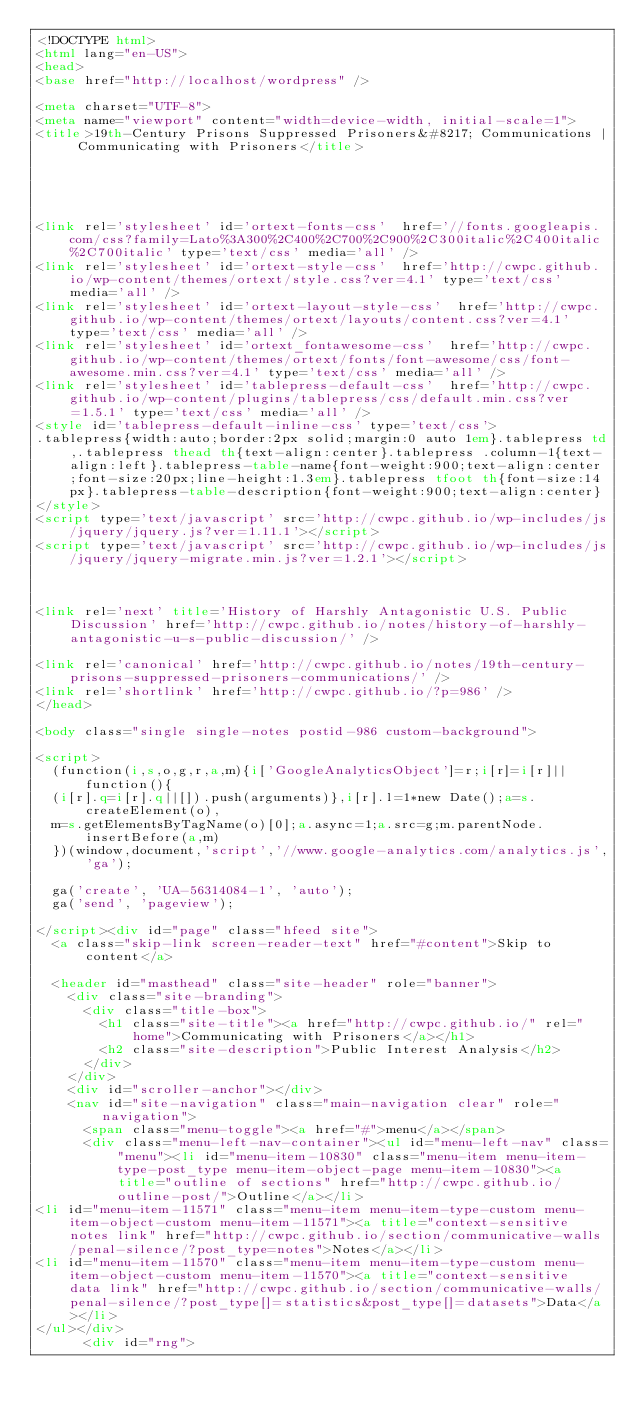Convert code to text. <code><loc_0><loc_0><loc_500><loc_500><_HTML_><!DOCTYPE html>
<html lang="en-US">
<head>
<base href="http://localhost/wordpress" />

<meta charset="UTF-8">
<meta name="viewport" content="width=device-width, initial-scale=1">
<title>19th-Century Prisons Suppressed Prisoners&#8217; Communications | Communicating with Prisoners</title>
 




<link rel='stylesheet' id='ortext-fonts-css'  href='//fonts.googleapis.com/css?family=Lato%3A300%2C400%2C700%2C900%2C300italic%2C400italic%2C700italic' type='text/css' media='all' />
<link rel='stylesheet' id='ortext-style-css'  href='http://cwpc.github.io/wp-content/themes/ortext/style.css?ver=4.1' type='text/css' media='all' />
<link rel='stylesheet' id='ortext-layout-style-css'  href='http://cwpc.github.io/wp-content/themes/ortext/layouts/content.css?ver=4.1' type='text/css' media='all' />
<link rel='stylesheet' id='ortext_fontawesome-css'  href='http://cwpc.github.io/wp-content/themes/ortext/fonts/font-awesome/css/font-awesome.min.css?ver=4.1' type='text/css' media='all' />
<link rel='stylesheet' id='tablepress-default-css'  href='http://cwpc.github.io/wp-content/plugins/tablepress/css/default.min.css?ver=1.5.1' type='text/css' media='all' />
<style id='tablepress-default-inline-css' type='text/css'>
.tablepress{width:auto;border:2px solid;margin:0 auto 1em}.tablepress td,.tablepress thead th{text-align:center}.tablepress .column-1{text-align:left}.tablepress-table-name{font-weight:900;text-align:center;font-size:20px;line-height:1.3em}.tablepress tfoot th{font-size:14px}.tablepress-table-description{font-weight:900;text-align:center}
</style>
<script type='text/javascript' src='http://cwpc.github.io/wp-includes/js/jquery/jquery.js?ver=1.11.1'></script>
<script type='text/javascript' src='http://cwpc.github.io/wp-includes/js/jquery/jquery-migrate.min.js?ver=1.2.1'></script>

 

<link rel='next' title='History of Harshly Antagonistic U.S. Public Discussion' href='http://cwpc.github.io/notes/history-of-harshly-antagonistic-u-s-public-discussion/' />

<link rel='canonical' href='http://cwpc.github.io/notes/19th-century-prisons-suppressed-prisoners-communications/' />
<link rel='shortlink' href='http://cwpc.github.io/?p=986' />
</head>

<body class="single single-notes postid-986 custom-background">

<script>
  (function(i,s,o,g,r,a,m){i['GoogleAnalyticsObject']=r;i[r]=i[r]||function(){
  (i[r].q=i[r].q||[]).push(arguments)},i[r].l=1*new Date();a=s.createElement(o),
  m=s.getElementsByTagName(o)[0];a.async=1;a.src=g;m.parentNode.insertBefore(a,m)
  })(window,document,'script','//www.google-analytics.com/analytics.js','ga');

  ga('create', 'UA-56314084-1', 'auto');
  ga('send', 'pageview');

</script><div id="page" class="hfeed site">
	<a class="skip-link screen-reader-text" href="#content">Skip to content</a>

	<header id="masthead" class="site-header" role="banner">
		<div class="site-branding">
			<div class="title-box">
				<h1 class="site-title"><a href="http://cwpc.github.io/" rel="home">Communicating with Prisoners</a></h1>
				<h2 class="site-description">Public Interest Analysis</h2>
			</div>
		</div>
		<div id="scroller-anchor"></div>
		<nav id="site-navigation" class="main-navigation clear" role="navigation">
			<span class="menu-toggle"><a href="#">menu</a></span>
			<div class="menu-left-nav-container"><ul id="menu-left-nav" class="menu"><li id="menu-item-10830" class="menu-item menu-item-type-post_type menu-item-object-page menu-item-10830"><a title="outline of sections" href="http://cwpc.github.io/outline-post/">Outline</a></li>
<li id="menu-item-11571" class="menu-item menu-item-type-custom menu-item-object-custom menu-item-11571"><a title="context-sensitive notes link" href="http://cwpc.github.io/section/communicative-walls/penal-silence/?post_type=notes">Notes</a></li>
<li id="menu-item-11570" class="menu-item menu-item-type-custom menu-item-object-custom menu-item-11570"><a title="context-sensitive data link" href="http://cwpc.github.io/section/communicative-walls/penal-silence/?post_type[]=statistics&post_type[]=datasets">Data</a></li>
</ul></div>			
			<div id="rng"></code> 